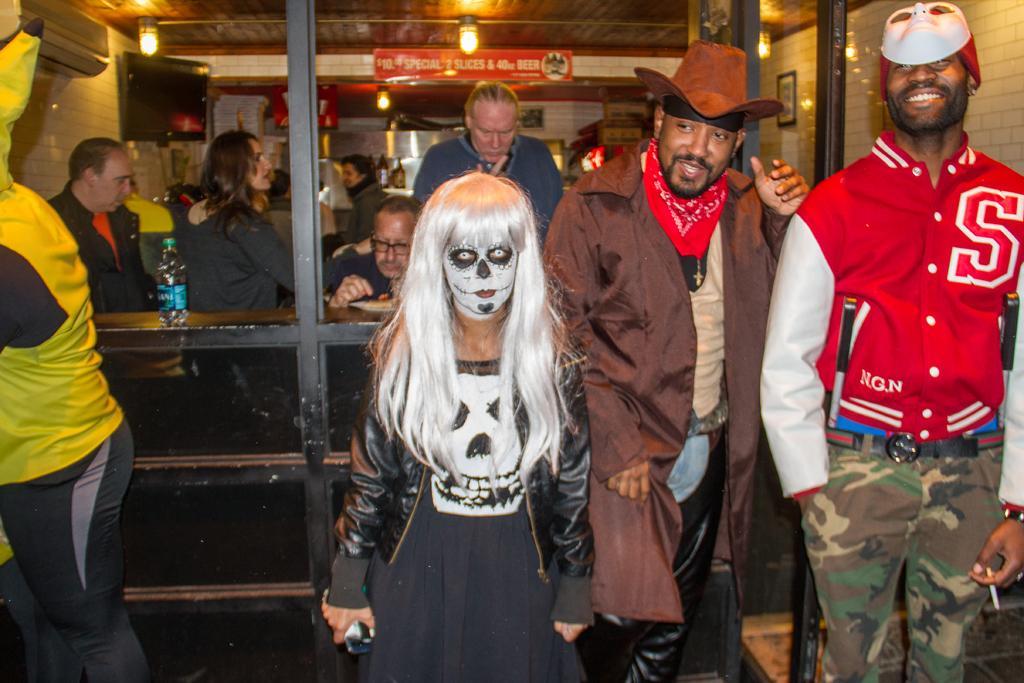Could you give a brief overview of what you see in this image? Here a woman is standing and she has a painting on her face. In the background there are few persons,lights on the ceiling,AC on the wall,bottles on a platform,name board,TV,frame on the wall and a bottle on a rack. On the right there is a hat on a man and another man has mask on his head. 